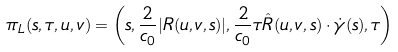Convert formula to latex. <formula><loc_0><loc_0><loc_500><loc_500>\pi _ { L } ( s , \tau , u , v ) = \left ( s , \frac { 2 } { c _ { 0 } } | R ( u , v , s ) | , \frac { 2 } { c _ { 0 } } \tau \hat { R } ( u , v , s ) \cdot \dot { \gamma } ( s ) , \tau \right )</formula> 